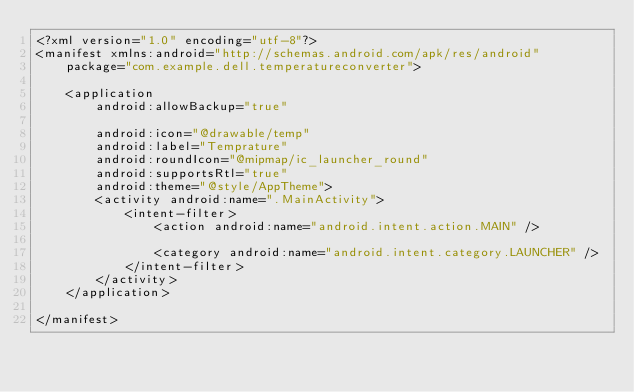Convert code to text. <code><loc_0><loc_0><loc_500><loc_500><_XML_><?xml version="1.0" encoding="utf-8"?>
<manifest xmlns:android="http://schemas.android.com/apk/res/android"
    package="com.example.dell.temperatureconverter">

    <application
        android:allowBackup="true"

        android:icon="@drawable/temp"
        android:label="Temprature"
        android:roundIcon="@mipmap/ic_launcher_round"
        android:supportsRtl="true"
        android:theme="@style/AppTheme">
        <activity android:name=".MainActivity">
            <intent-filter>
                <action android:name="android.intent.action.MAIN" />

                <category android:name="android.intent.category.LAUNCHER" />
            </intent-filter>
        </activity>
    </application>

</manifest></code> 